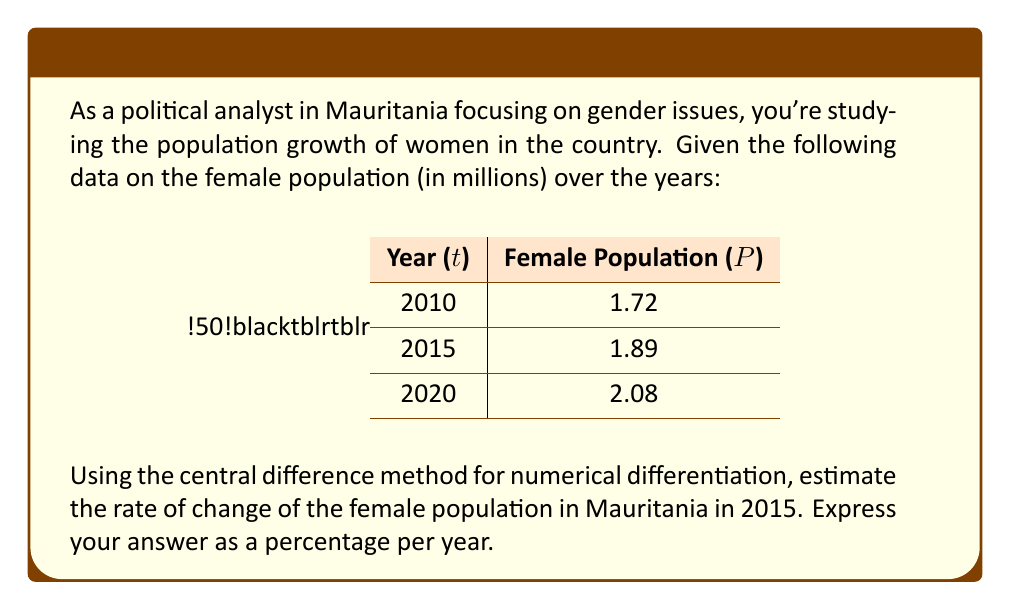Can you answer this question? To solve this problem, we'll use the central difference method for numerical differentiation. This method provides a good approximation of the derivative (rate of change) at a point using data from both sides of that point.

The central difference formula is:

$$f'(x) \approx \frac{f(x+h) - f(x-h)}{2h}$$

Where $f'(x)$ is the derivative (rate of change) at point $x$, and $h$ is the step size.

In our case:
- $x$ represents the year 2015
- $f(x)$ represents the female population in 2015
- $h$ represents the time step, which is 5 years

Let's apply the formula:

1) Identify the values:
   $f(x-h) = f(2010) = 1.72$ million
   $f(x+h) = f(2020) = 2.08$ million
   $h = 5$ years

2) Apply the central difference formula:
   $$f'(2015) \approx \frac{f(2020) - f(2010)}{2(5)} = \frac{2.08 - 1.72}{10} = 0.036$$

3) This gives us the rate of change in millions per year. To convert to a percentage:
   $0.036 \text{ million/year} = 36,000 \text{ per year}$

4) To express as a percentage of the 2015 population:
   $$\text{Percentage growth} = \frac{36,000}{1.89 \text{ million}} \times 100\% = 1.90\% \text{ per year}$$

Therefore, the estimated rate of change of the female population in Mauritania in 2015 is approximately 1.90% per year.
Answer: 1.90% per year 